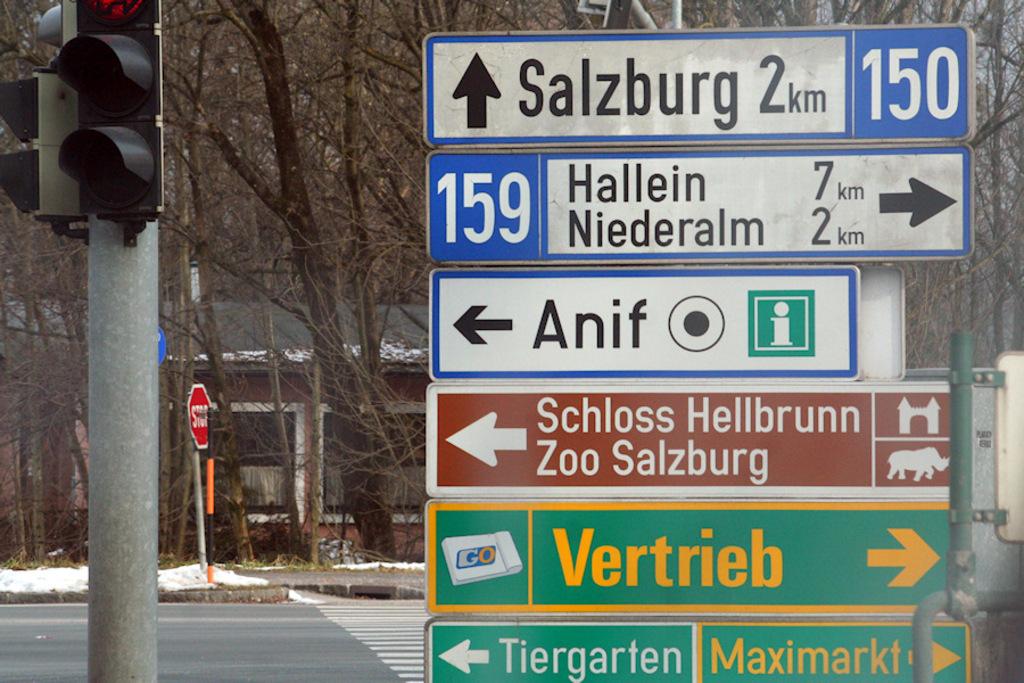What are the names of these cities?
Offer a terse response. Salzburg, hallein, niederalm, anif, vertrieb, tiergarten, maximarkt. How far to salzburg?
Give a very brief answer. 2km. 